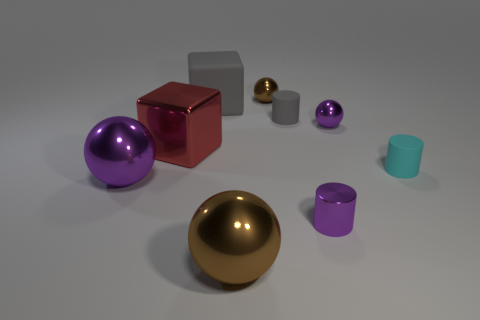What is the color of the small rubber thing that is to the right of the tiny purple shiny cylinder?
Provide a succinct answer. Cyan. Is there a thing on the right side of the small sphere in front of the rubber cube?
Your answer should be very brief. Yes. There is a large metal ball to the right of the big red thing; does it have the same color as the tiny ball that is to the left of the purple metal cylinder?
Offer a terse response. Yes. There is a large brown ball; what number of small rubber cylinders are behind it?
Keep it short and to the point. 2. How many tiny matte cylinders are the same color as the rubber cube?
Your answer should be very brief. 1. Does the large cube right of the red metallic block have the same material as the cyan thing?
Keep it short and to the point. Yes. How many small cyan cylinders have the same material as the gray cylinder?
Offer a very short reply. 1. Is the number of objects left of the tiny cyan cylinder greater than the number of cyan rubber objects?
Offer a terse response. Yes. There is another rubber object that is the same color as the large rubber object; what size is it?
Your response must be concise. Small. Are there any large brown metallic objects of the same shape as the tiny brown object?
Provide a succinct answer. Yes. 